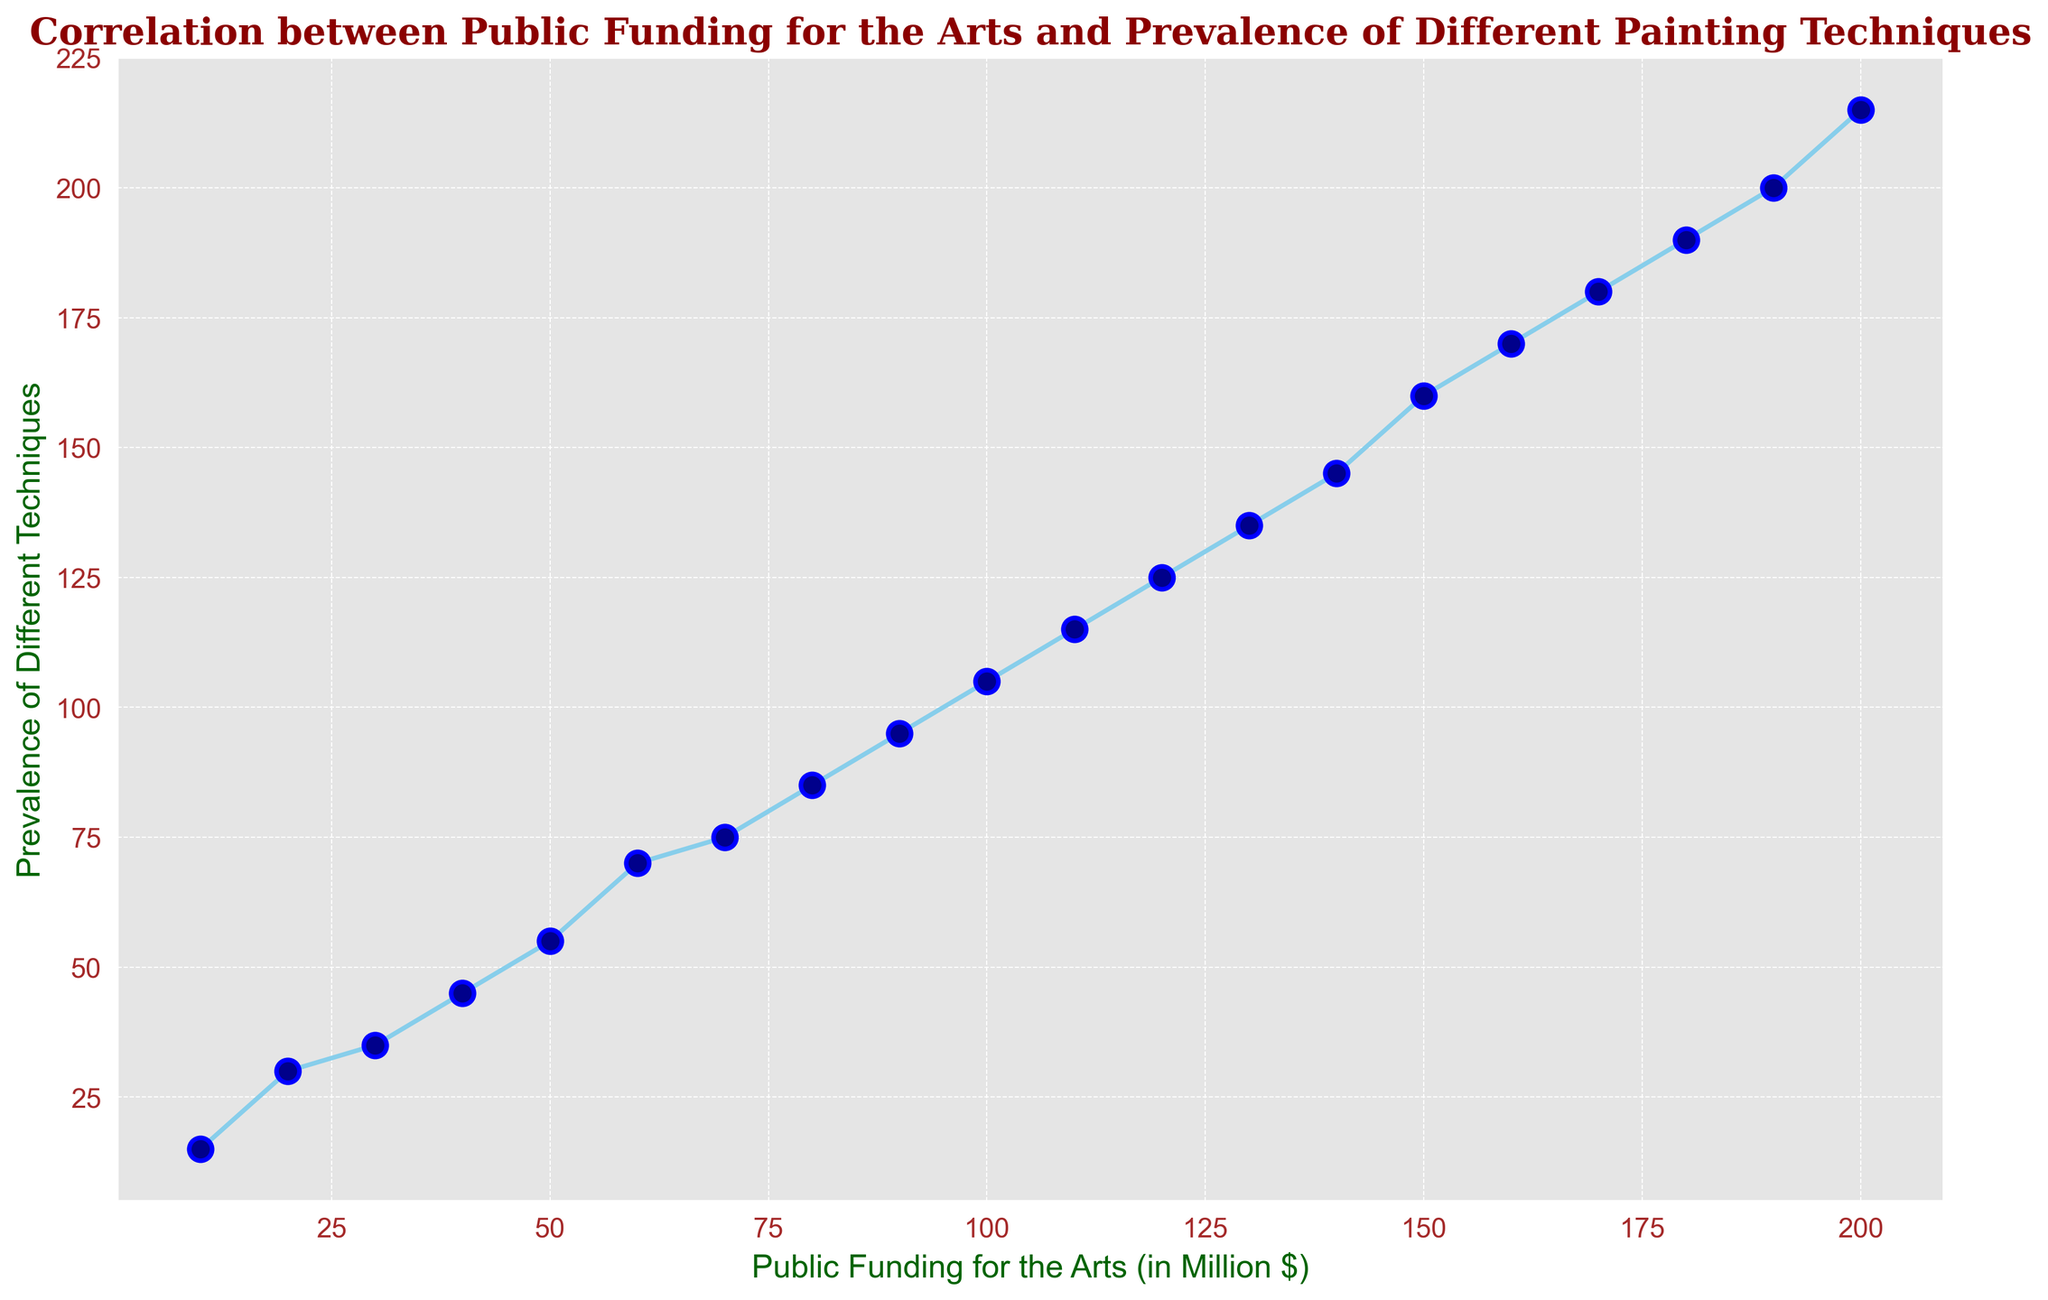What's the relationship between public funding and the prevalence of different techniques? The plot shows a generally increasing trend where higher public funding corresponds to a higher prevalence of different painting techniques. This suggests a positive correlation between the two variables.
Answer: Positive correlation At what funding amount does the prevalence of different techniques first reach 100? By examining the graph, the prevalence of different techniques reaches 100 when public funding is 80 million dollars.
Answer: 80 million dollars Compare the prevalence of different techniques when public funding is twice as much as 50 million dollars. When public funding is 100 million dollars, the prevalence is 105. When public funding is 50 million dollars, the prevalence is 55. Comparing both, when funding is doubled, the prevalence increases from 55 to 105, indicating a significant rise.
Answer: 105 vs. 55 What is the total funding amount shown in the data? The funding amounts range from 10 million to 200 million. Summing these values using the given dataset yields 10+20+30+40+50+60+70+80+90+100+110+120+130+140+150+160+170+180+190+200 = 2100 million dollars.
Answer: 2100 million dollars By how much does the prevalence of different techniques increase when funding goes from 10 million to 50 million dollars? At 10 million dollars, the prevalence is 15. At 50 million dollars, the prevalence is 55. Therefore, the increase in prevalence is 55 - 15 = 40.
Answer: 40 What is the slope of the line when public funding increases from 160 million to 180 million dollars? The corresponding prevalence values at these points are 170 and 190. The slope can be calculated as (190 - 170) / (180 - 160) = 20 / 20 = 1.
Answer: 1 How does the rate of prevalence change as public funding increases from 190 million to 200 million dollars compared to other segments? In this segment, the prevalence increases from 200 to 215, a change of 15 units for a 10 million dollar increase in funding. Compared to the other segments, this is a relatively higher rate of change.
Answer: Higher rate of change Is there any funding amount where the prevalence does not increase with increased funding? By examining the plot, the prevalence consistently increases without any dips as the funding amount increases, indicating there are no such points.
Answer: No What is the average prevalence of different techniques when the public funding is below 100 million dollars? Funding below 100 million dollars includes (10, 20, 30, 40, 50, 60, 70, 80, 90). Corresponding prevalence values are (15, 30, 35, 45, 55, 70, 75, 85, 95). The average is (15+30+35+45+55+70+75+85+95) / 9 = 505 / 9 ≈ 56.11.
Answer: 56.11 